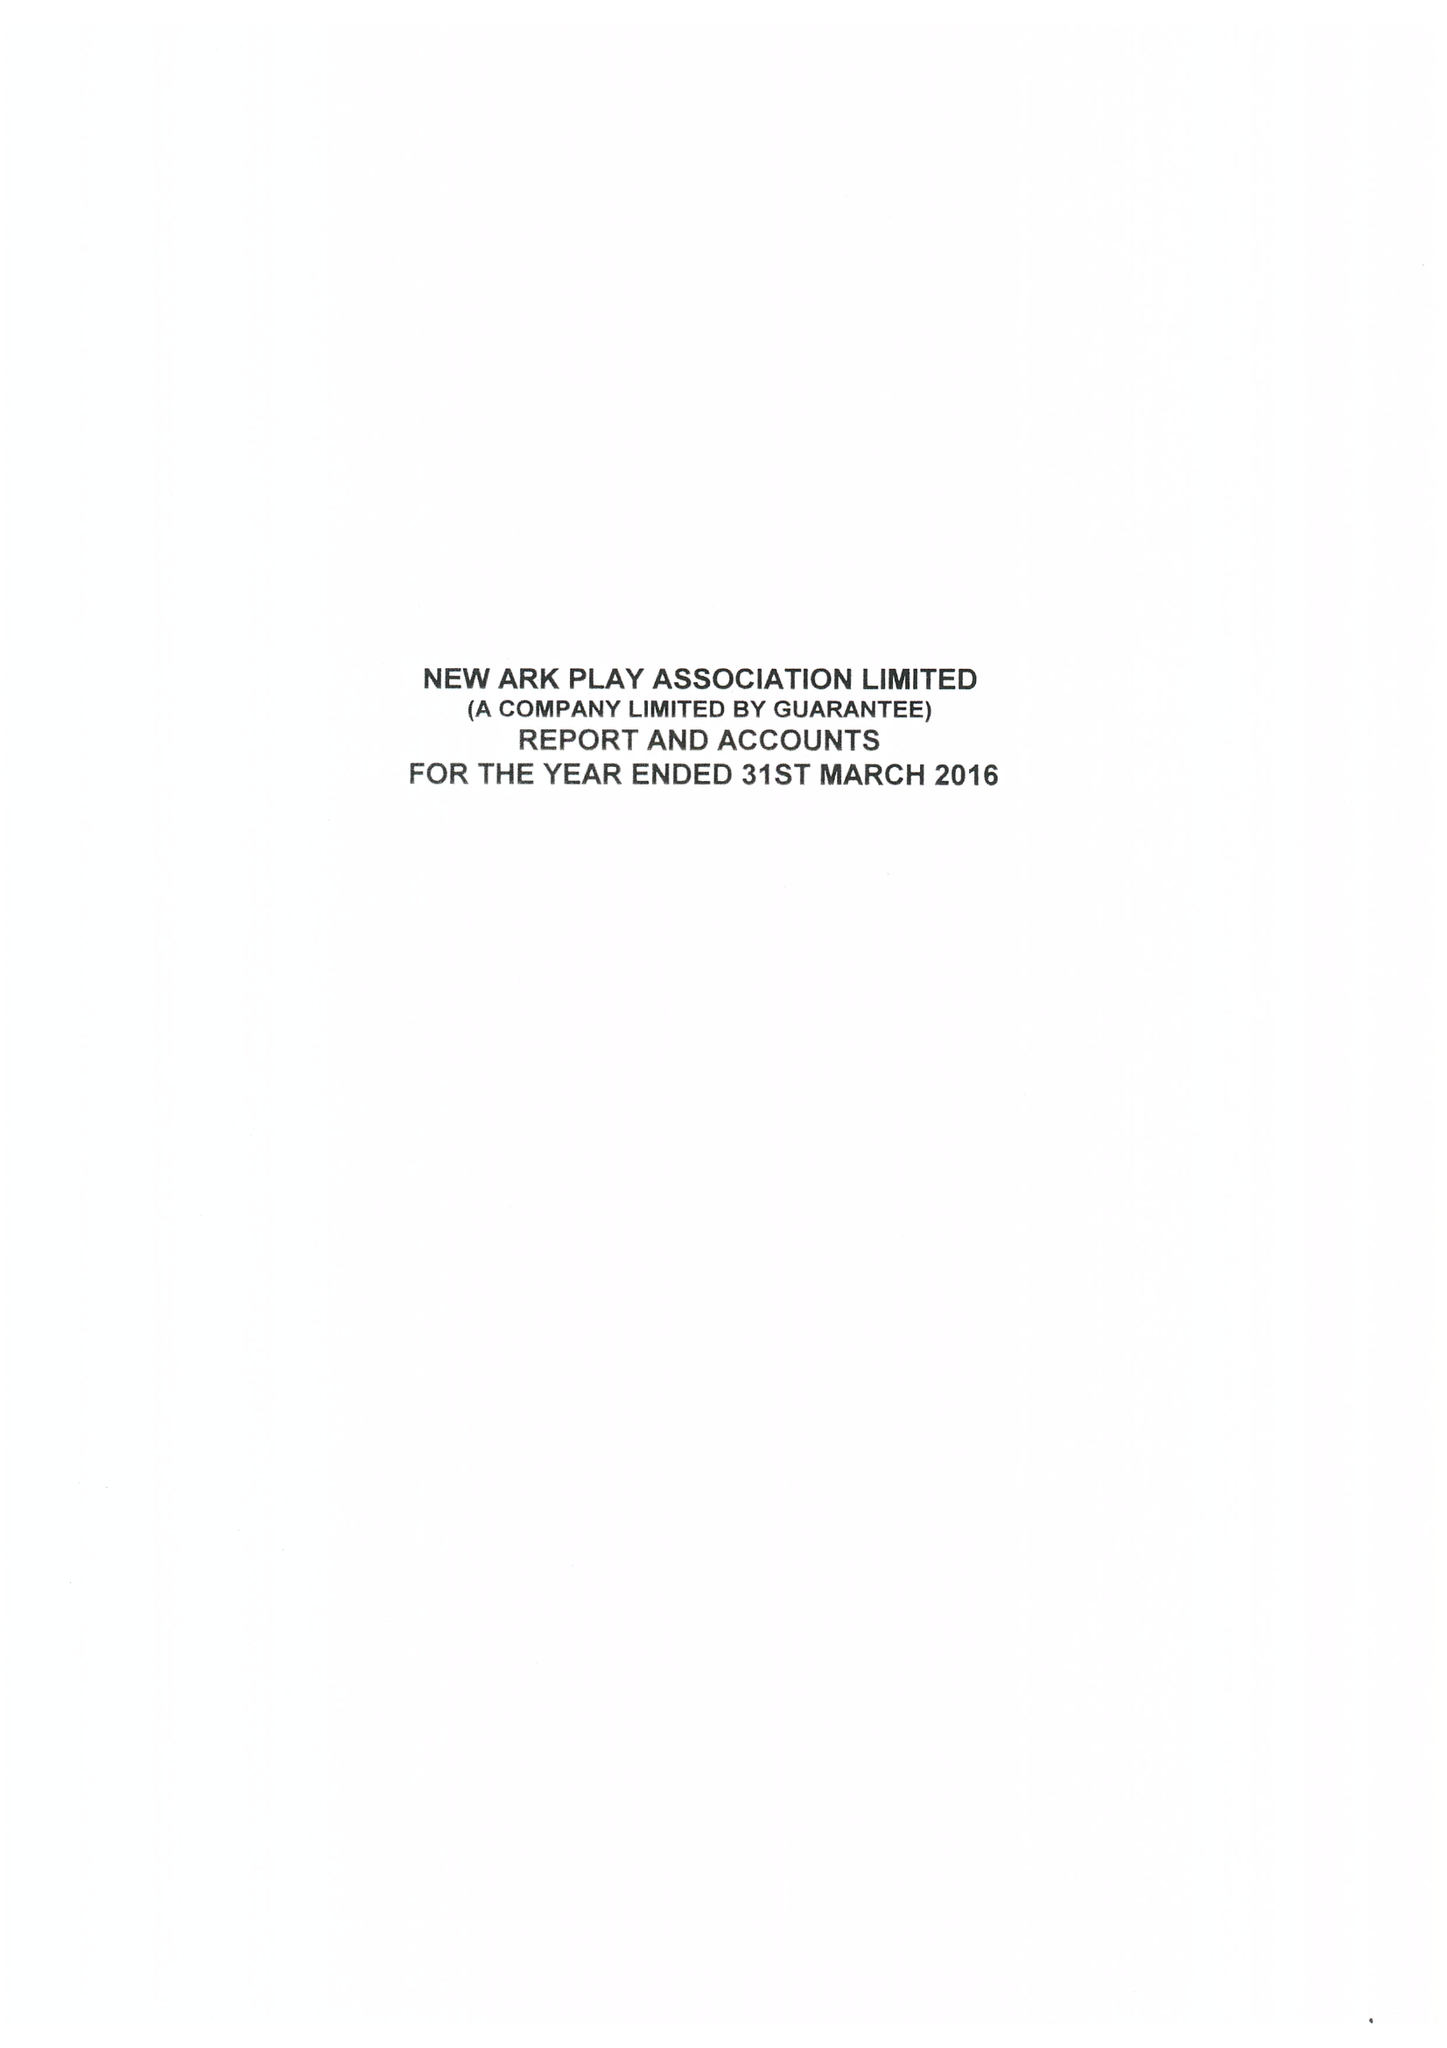What is the value for the address__post_town?
Answer the question using a single word or phrase. PETERBOROUGH 